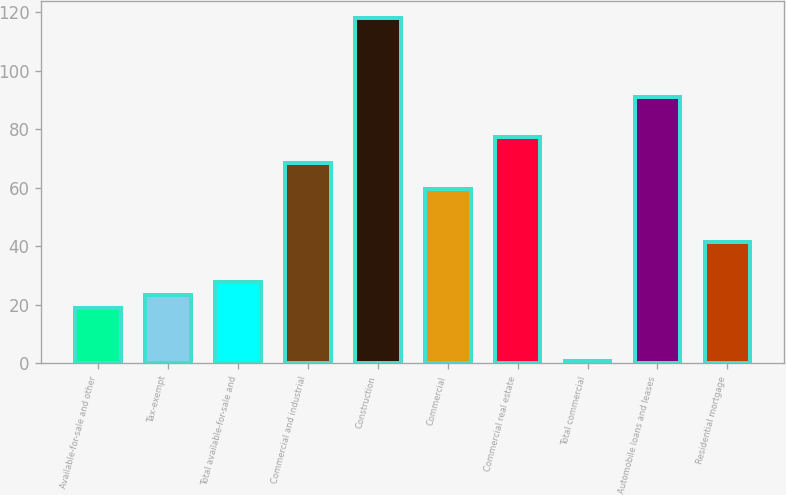Convert chart to OTSL. <chart><loc_0><loc_0><loc_500><loc_500><bar_chart><fcel>Available-for-sale and other<fcel>Tax-exempt<fcel>Total available-for-sale and<fcel>Commercial and industrial<fcel>Construction<fcel>Commercial<fcel>Commercial real estate<fcel>Total commercial<fcel>Automobile loans and leases<fcel>Residential mortgage<nl><fcel>19<fcel>23.5<fcel>28<fcel>68.5<fcel>118<fcel>59.5<fcel>77.5<fcel>1<fcel>91<fcel>41.5<nl></chart> 